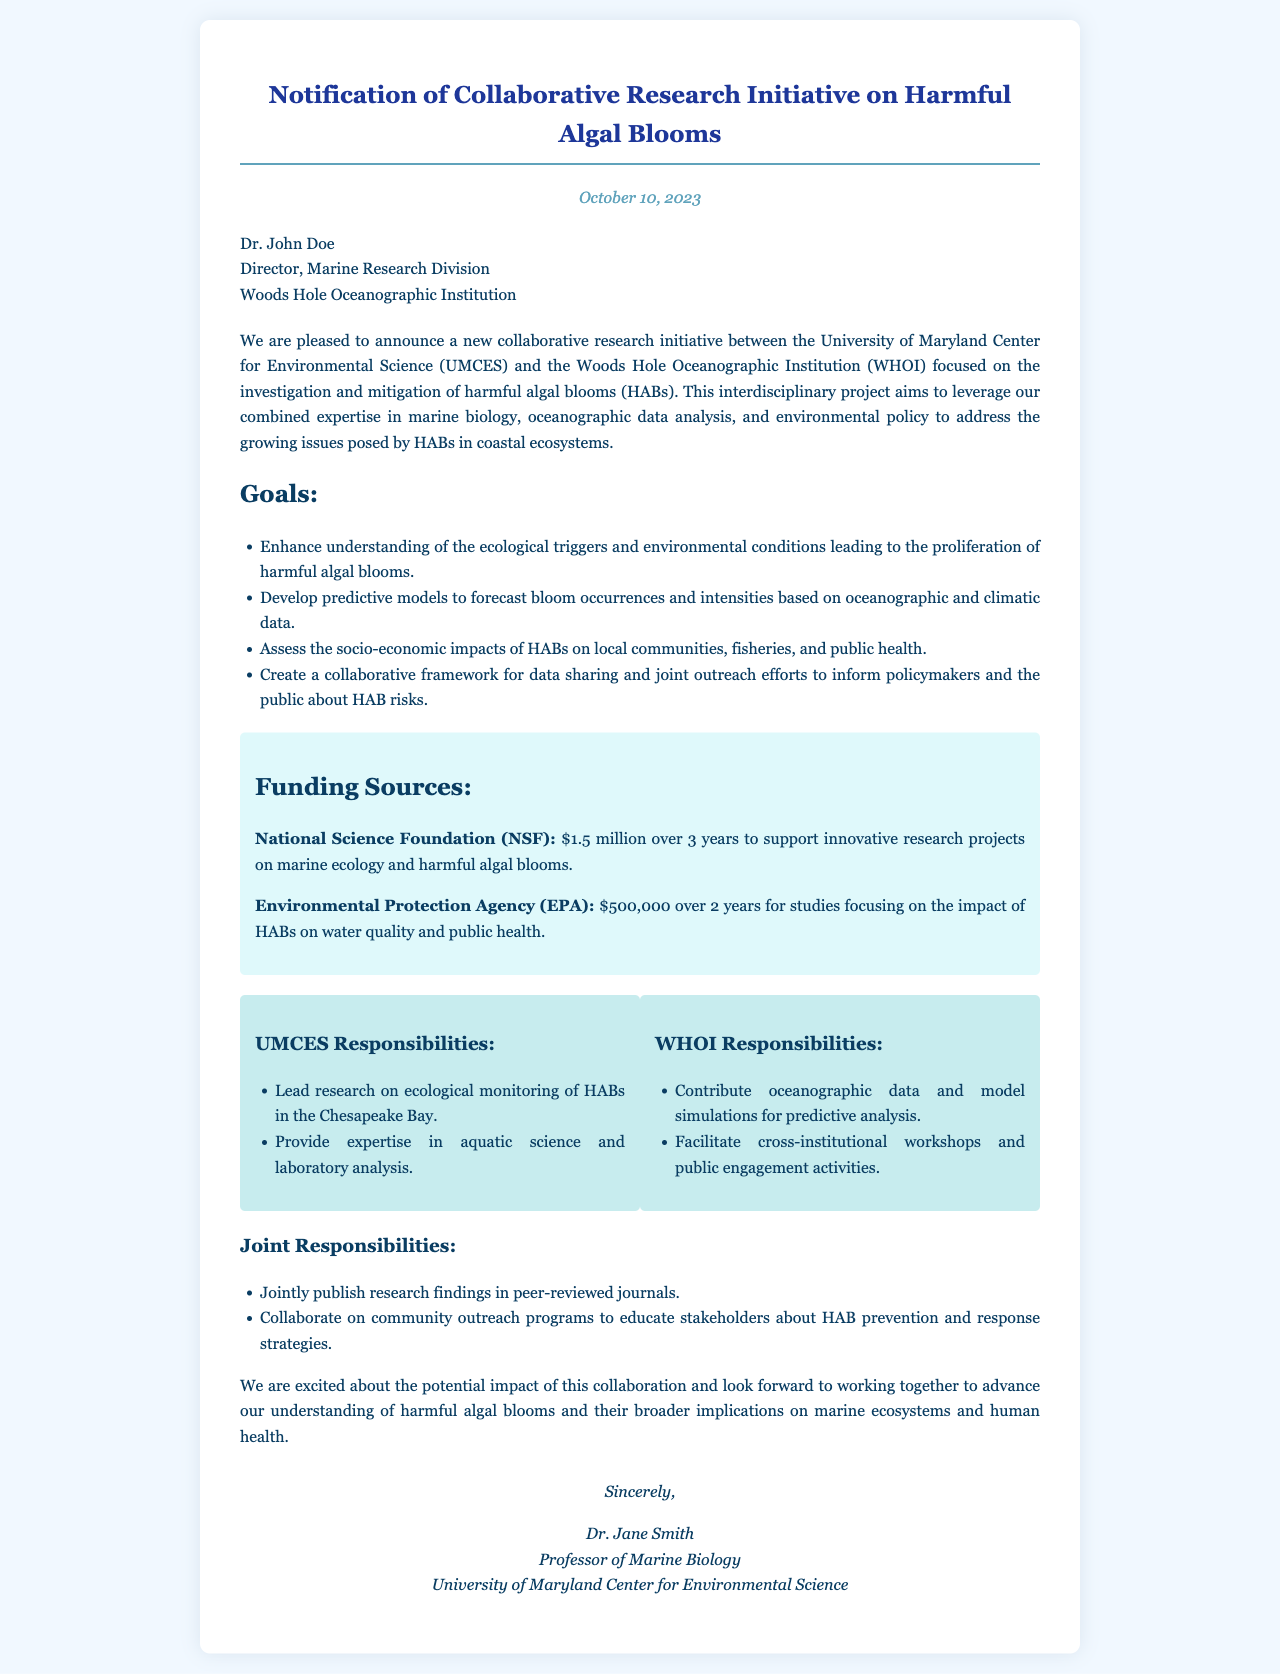What is the date of the announcement? The date of the announcement is stated at the beginning of the document, which is October 10, 2023.
Answer: October 10, 2023 Who is the recipient of the letter? The recipient's name and title are listed in the document, specifically Dr. John Doe, Director of Marine Research Division.
Answer: Dr. John Doe What is the total funding from the National Science Foundation? The document specifies the funding amount from NSF, which is stated as $1.5 million over 3 years.
Answer: $1.5 million What is one goal of the research initiative? The document lists several goals, one of which is to enhance understanding of the ecological triggers and environmental conditions of harmful algal blooms.
Answer: Enhance understanding of the ecological triggers What are UMCES's responsibilities in the initiative? UMCES’s responsibilities are outlined in a section of the document, detailing that they will lead research on ecological monitoring of HABs in the Chesapeake Bay.
Answer: Lead research on ecological monitoring of HABs in the Chesapeake Bay How many years of funding does the EPA provide? The funding duration from the EPA is specified in the document, which is noted as 2 years.
Answer: 2 years What type of document is this? The document is identified by its structure and content as a notification letter regarding a collaborative research initiative.
Answer: Notification letter 